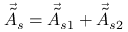Convert formula to latex. <formula><loc_0><loc_0><loc_500><loc_500>\vec { \tilde { A } } _ { s } = \vec { \tilde { A } } _ { s 1 } + \vec { \tilde { A } } _ { s 2 }</formula> 